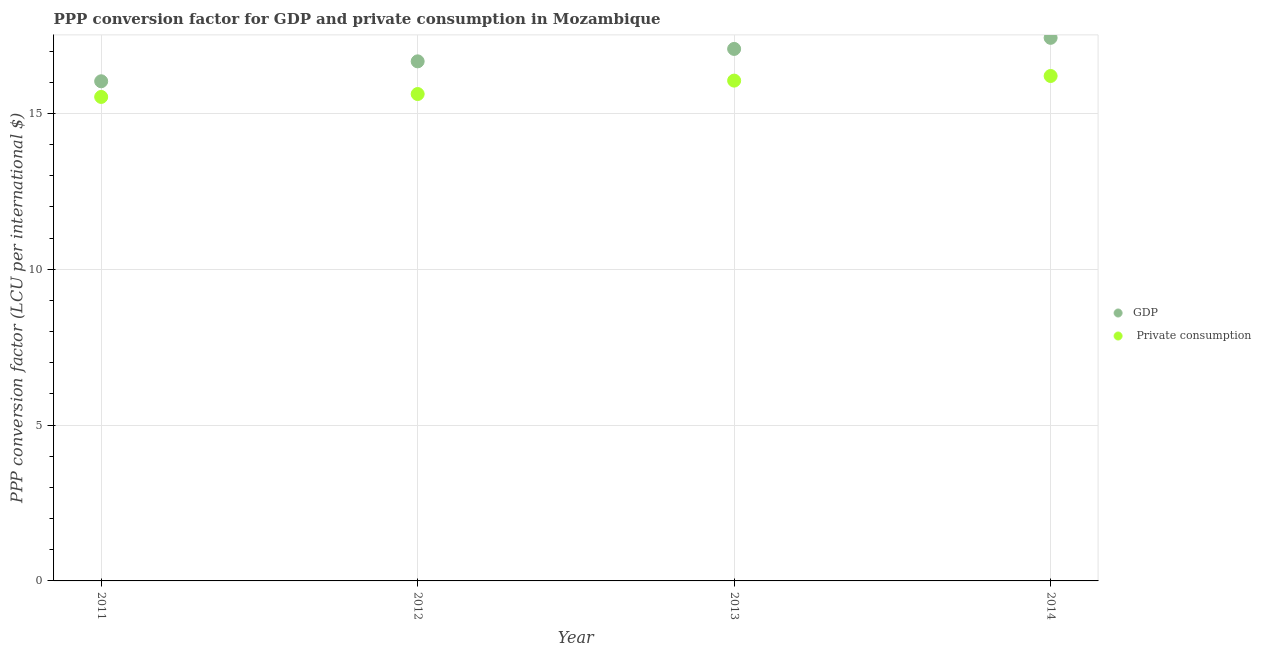Is the number of dotlines equal to the number of legend labels?
Your answer should be very brief. Yes. What is the ppp conversion factor for gdp in 2011?
Your response must be concise. 16.03. Across all years, what is the maximum ppp conversion factor for gdp?
Make the answer very short. 17.42. Across all years, what is the minimum ppp conversion factor for private consumption?
Make the answer very short. 15.53. In which year was the ppp conversion factor for private consumption minimum?
Offer a terse response. 2011. What is the total ppp conversion factor for private consumption in the graph?
Make the answer very short. 63.4. What is the difference between the ppp conversion factor for private consumption in 2011 and that in 2014?
Offer a very short reply. -0.67. What is the difference between the ppp conversion factor for private consumption in 2011 and the ppp conversion factor for gdp in 2012?
Offer a very short reply. -1.14. What is the average ppp conversion factor for gdp per year?
Provide a succinct answer. 16.8. In the year 2011, what is the difference between the ppp conversion factor for gdp and ppp conversion factor for private consumption?
Provide a short and direct response. 0.5. What is the ratio of the ppp conversion factor for gdp in 2011 to that in 2014?
Ensure brevity in your answer.  0.92. Is the difference between the ppp conversion factor for private consumption in 2012 and 2014 greater than the difference between the ppp conversion factor for gdp in 2012 and 2014?
Ensure brevity in your answer.  Yes. What is the difference between the highest and the second highest ppp conversion factor for private consumption?
Your answer should be very brief. 0.15. What is the difference between the highest and the lowest ppp conversion factor for private consumption?
Provide a succinct answer. 0.67. Does the ppp conversion factor for private consumption monotonically increase over the years?
Offer a terse response. Yes. Is the ppp conversion factor for private consumption strictly less than the ppp conversion factor for gdp over the years?
Your answer should be very brief. Yes. How many dotlines are there?
Keep it short and to the point. 2. What is the difference between two consecutive major ticks on the Y-axis?
Your answer should be compact. 5. Does the graph contain any zero values?
Give a very brief answer. No. Does the graph contain grids?
Offer a terse response. Yes. Where does the legend appear in the graph?
Keep it short and to the point. Center right. What is the title of the graph?
Ensure brevity in your answer.  PPP conversion factor for GDP and private consumption in Mozambique. Does "Taxes on profits and capital gains" appear as one of the legend labels in the graph?
Provide a succinct answer. No. What is the label or title of the Y-axis?
Offer a terse response. PPP conversion factor (LCU per international $). What is the PPP conversion factor (LCU per international $) of GDP in 2011?
Offer a very short reply. 16.03. What is the PPP conversion factor (LCU per international $) of  Private consumption in 2011?
Provide a succinct answer. 15.53. What is the PPP conversion factor (LCU per international $) of GDP in 2012?
Offer a terse response. 16.67. What is the PPP conversion factor (LCU per international $) in  Private consumption in 2012?
Make the answer very short. 15.62. What is the PPP conversion factor (LCU per international $) in GDP in 2013?
Make the answer very short. 17.07. What is the PPP conversion factor (LCU per international $) in  Private consumption in 2013?
Provide a short and direct response. 16.05. What is the PPP conversion factor (LCU per international $) in GDP in 2014?
Keep it short and to the point. 17.42. What is the PPP conversion factor (LCU per international $) in  Private consumption in 2014?
Ensure brevity in your answer.  16.2. Across all years, what is the maximum PPP conversion factor (LCU per international $) in GDP?
Provide a succinct answer. 17.42. Across all years, what is the maximum PPP conversion factor (LCU per international $) in  Private consumption?
Your response must be concise. 16.2. Across all years, what is the minimum PPP conversion factor (LCU per international $) of GDP?
Your response must be concise. 16.03. Across all years, what is the minimum PPP conversion factor (LCU per international $) in  Private consumption?
Your response must be concise. 15.53. What is the total PPP conversion factor (LCU per international $) in GDP in the graph?
Offer a terse response. 67.19. What is the total PPP conversion factor (LCU per international $) of  Private consumption in the graph?
Provide a succinct answer. 63.4. What is the difference between the PPP conversion factor (LCU per international $) of GDP in 2011 and that in 2012?
Provide a succinct answer. -0.64. What is the difference between the PPP conversion factor (LCU per international $) in  Private consumption in 2011 and that in 2012?
Keep it short and to the point. -0.09. What is the difference between the PPP conversion factor (LCU per international $) of GDP in 2011 and that in 2013?
Offer a very short reply. -1.04. What is the difference between the PPP conversion factor (LCU per international $) of  Private consumption in 2011 and that in 2013?
Offer a terse response. -0.52. What is the difference between the PPP conversion factor (LCU per international $) of GDP in 2011 and that in 2014?
Keep it short and to the point. -1.39. What is the difference between the PPP conversion factor (LCU per international $) of  Private consumption in 2011 and that in 2014?
Your answer should be compact. -0.67. What is the difference between the PPP conversion factor (LCU per international $) of GDP in 2012 and that in 2013?
Your answer should be very brief. -0.4. What is the difference between the PPP conversion factor (LCU per international $) of  Private consumption in 2012 and that in 2013?
Provide a short and direct response. -0.43. What is the difference between the PPP conversion factor (LCU per international $) of GDP in 2012 and that in 2014?
Ensure brevity in your answer.  -0.75. What is the difference between the PPP conversion factor (LCU per international $) in  Private consumption in 2012 and that in 2014?
Ensure brevity in your answer.  -0.58. What is the difference between the PPP conversion factor (LCU per international $) in GDP in 2013 and that in 2014?
Provide a short and direct response. -0.36. What is the difference between the PPP conversion factor (LCU per international $) of  Private consumption in 2013 and that in 2014?
Make the answer very short. -0.15. What is the difference between the PPP conversion factor (LCU per international $) of GDP in 2011 and the PPP conversion factor (LCU per international $) of  Private consumption in 2012?
Ensure brevity in your answer.  0.41. What is the difference between the PPP conversion factor (LCU per international $) of GDP in 2011 and the PPP conversion factor (LCU per international $) of  Private consumption in 2013?
Your answer should be compact. -0.02. What is the difference between the PPP conversion factor (LCU per international $) of GDP in 2011 and the PPP conversion factor (LCU per international $) of  Private consumption in 2014?
Ensure brevity in your answer.  -0.17. What is the difference between the PPP conversion factor (LCU per international $) of GDP in 2012 and the PPP conversion factor (LCU per international $) of  Private consumption in 2013?
Your answer should be compact. 0.62. What is the difference between the PPP conversion factor (LCU per international $) in GDP in 2012 and the PPP conversion factor (LCU per international $) in  Private consumption in 2014?
Offer a very short reply. 0.47. What is the difference between the PPP conversion factor (LCU per international $) of GDP in 2013 and the PPP conversion factor (LCU per international $) of  Private consumption in 2014?
Your answer should be very brief. 0.87. What is the average PPP conversion factor (LCU per international $) in GDP per year?
Keep it short and to the point. 16.8. What is the average PPP conversion factor (LCU per international $) in  Private consumption per year?
Provide a succinct answer. 15.85. In the year 2011, what is the difference between the PPP conversion factor (LCU per international $) of GDP and PPP conversion factor (LCU per international $) of  Private consumption?
Keep it short and to the point. 0.5. In the year 2012, what is the difference between the PPP conversion factor (LCU per international $) of GDP and PPP conversion factor (LCU per international $) of  Private consumption?
Your answer should be compact. 1.05. In the year 2013, what is the difference between the PPP conversion factor (LCU per international $) of GDP and PPP conversion factor (LCU per international $) of  Private consumption?
Keep it short and to the point. 1.02. In the year 2014, what is the difference between the PPP conversion factor (LCU per international $) in GDP and PPP conversion factor (LCU per international $) in  Private consumption?
Provide a succinct answer. 1.22. What is the ratio of the PPP conversion factor (LCU per international $) of GDP in 2011 to that in 2012?
Provide a short and direct response. 0.96. What is the ratio of the PPP conversion factor (LCU per international $) in  Private consumption in 2011 to that in 2012?
Keep it short and to the point. 0.99. What is the ratio of the PPP conversion factor (LCU per international $) in GDP in 2011 to that in 2013?
Your answer should be very brief. 0.94. What is the ratio of the PPP conversion factor (LCU per international $) of  Private consumption in 2011 to that in 2013?
Your answer should be compact. 0.97. What is the ratio of the PPP conversion factor (LCU per international $) of GDP in 2011 to that in 2014?
Offer a terse response. 0.92. What is the ratio of the PPP conversion factor (LCU per international $) of  Private consumption in 2011 to that in 2014?
Your response must be concise. 0.96. What is the ratio of the PPP conversion factor (LCU per international $) in GDP in 2012 to that in 2013?
Keep it short and to the point. 0.98. What is the ratio of the PPP conversion factor (LCU per international $) in  Private consumption in 2012 to that in 2013?
Provide a succinct answer. 0.97. What is the ratio of the PPP conversion factor (LCU per international $) in GDP in 2012 to that in 2014?
Provide a succinct answer. 0.96. What is the ratio of the PPP conversion factor (LCU per international $) of  Private consumption in 2012 to that in 2014?
Offer a very short reply. 0.96. What is the ratio of the PPP conversion factor (LCU per international $) in GDP in 2013 to that in 2014?
Offer a terse response. 0.98. What is the ratio of the PPP conversion factor (LCU per international $) in  Private consumption in 2013 to that in 2014?
Offer a terse response. 0.99. What is the difference between the highest and the second highest PPP conversion factor (LCU per international $) in GDP?
Ensure brevity in your answer.  0.36. What is the difference between the highest and the second highest PPP conversion factor (LCU per international $) of  Private consumption?
Offer a terse response. 0.15. What is the difference between the highest and the lowest PPP conversion factor (LCU per international $) in GDP?
Your answer should be compact. 1.39. What is the difference between the highest and the lowest PPP conversion factor (LCU per international $) in  Private consumption?
Keep it short and to the point. 0.67. 